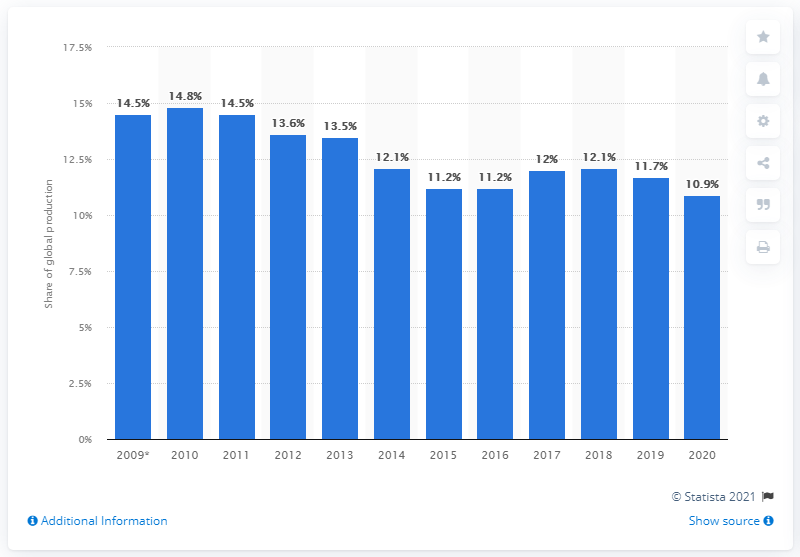Highlight a few significant elements in this photo. In 2020, Gazprom accounted for 10.9% of the world's natural gas production. 